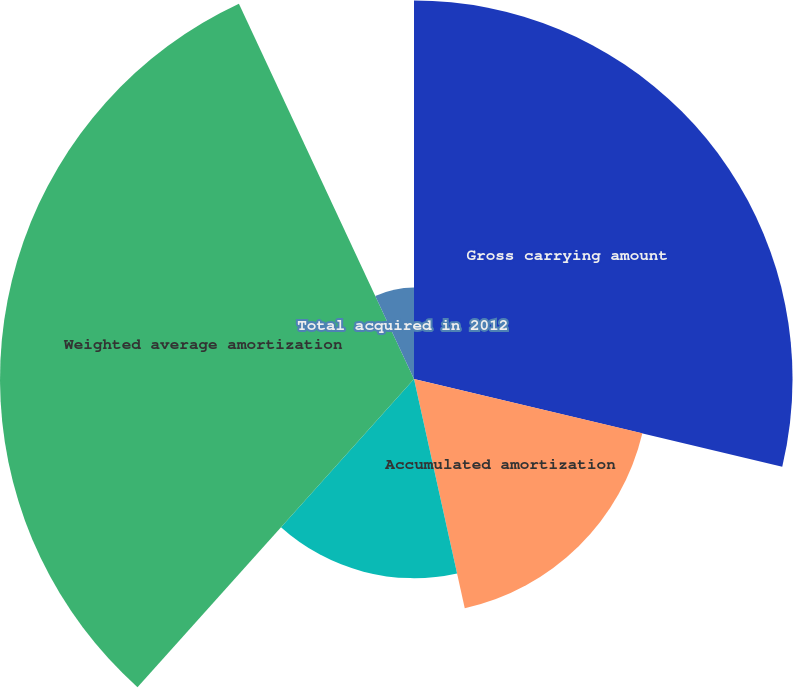Convert chart to OTSL. <chart><loc_0><loc_0><loc_500><loc_500><pie_chart><fcel>Gross carrying amount<fcel>Accumulated amortization<fcel>Net other intangibles as of<fcel>Weighted average amortization<fcel>Total acquired in 2012<nl><fcel>28.72%<fcel>17.81%<fcel>15.11%<fcel>31.41%<fcel>6.95%<nl></chart> 